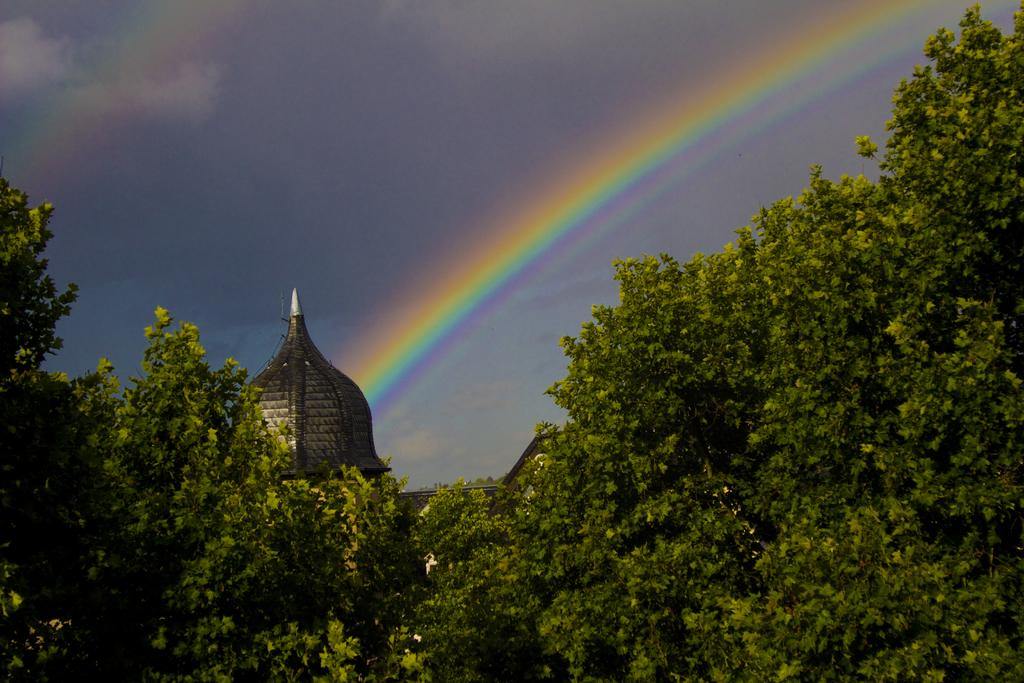What type of natural elements can be seen in the image? There are trees in the image. What type of man-made structure is present in the image? There is a building in the image. Where is the building located in the image? The building is in the center of the image. What can be seen in the background of the image? There is a rainbow and the sky visible in the background of the image. What type of engine can be seen powering the wheel in the image? There is no engine or wheel present in the image. What time is displayed on the clock in the image? There is no clock present in the image. 